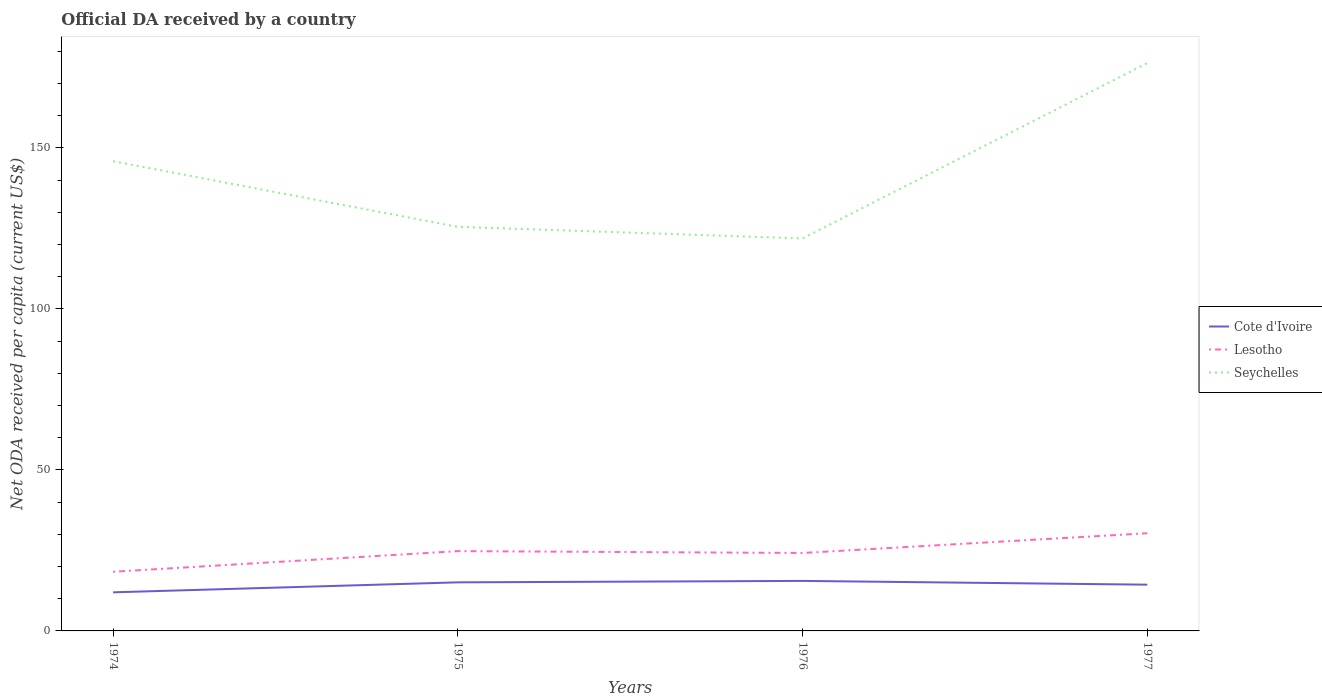How many different coloured lines are there?
Your answer should be very brief. 3. Does the line corresponding to Lesotho intersect with the line corresponding to Cote d'Ivoire?
Provide a succinct answer. No. Is the number of lines equal to the number of legend labels?
Your answer should be very brief. Yes. Across all years, what is the maximum ODA received in in Seychelles?
Make the answer very short. 121.9. In which year was the ODA received in in Seychelles maximum?
Ensure brevity in your answer.  1976. What is the total ODA received in in Seychelles in the graph?
Your answer should be very brief. -50.88. What is the difference between the highest and the second highest ODA received in in Seychelles?
Offer a terse response. 54.48. What is the difference between the highest and the lowest ODA received in in Seychelles?
Give a very brief answer. 2. How many lines are there?
Give a very brief answer. 3. How many years are there in the graph?
Offer a terse response. 4. Are the values on the major ticks of Y-axis written in scientific E-notation?
Keep it short and to the point. No. Where does the legend appear in the graph?
Make the answer very short. Center right. What is the title of the graph?
Offer a very short reply. Official DA received by a country. What is the label or title of the X-axis?
Offer a terse response. Years. What is the label or title of the Y-axis?
Your response must be concise. Net ODA received per capita (current US$). What is the Net ODA received per capita (current US$) of Cote d'Ivoire in 1974?
Give a very brief answer. 11.99. What is the Net ODA received per capita (current US$) in Lesotho in 1974?
Provide a succinct answer. 18.37. What is the Net ODA received per capita (current US$) in Seychelles in 1974?
Keep it short and to the point. 145.9. What is the Net ODA received per capita (current US$) of Cote d'Ivoire in 1975?
Your answer should be compact. 15.09. What is the Net ODA received per capita (current US$) in Lesotho in 1975?
Your response must be concise. 24.78. What is the Net ODA received per capita (current US$) of Seychelles in 1975?
Keep it short and to the point. 125.5. What is the Net ODA received per capita (current US$) of Cote d'Ivoire in 1976?
Ensure brevity in your answer.  15.54. What is the Net ODA received per capita (current US$) in Lesotho in 1976?
Keep it short and to the point. 24.21. What is the Net ODA received per capita (current US$) of Seychelles in 1976?
Keep it short and to the point. 121.9. What is the Net ODA received per capita (current US$) of Cote d'Ivoire in 1977?
Provide a short and direct response. 14.36. What is the Net ODA received per capita (current US$) in Lesotho in 1977?
Your answer should be compact. 30.33. What is the Net ODA received per capita (current US$) in Seychelles in 1977?
Your response must be concise. 176.38. Across all years, what is the maximum Net ODA received per capita (current US$) of Cote d'Ivoire?
Provide a short and direct response. 15.54. Across all years, what is the maximum Net ODA received per capita (current US$) in Lesotho?
Offer a terse response. 30.33. Across all years, what is the maximum Net ODA received per capita (current US$) of Seychelles?
Provide a succinct answer. 176.38. Across all years, what is the minimum Net ODA received per capita (current US$) of Cote d'Ivoire?
Keep it short and to the point. 11.99. Across all years, what is the minimum Net ODA received per capita (current US$) of Lesotho?
Provide a short and direct response. 18.37. Across all years, what is the minimum Net ODA received per capita (current US$) of Seychelles?
Ensure brevity in your answer.  121.9. What is the total Net ODA received per capita (current US$) of Cote d'Ivoire in the graph?
Your answer should be compact. 56.98. What is the total Net ODA received per capita (current US$) in Lesotho in the graph?
Your answer should be compact. 97.7. What is the total Net ODA received per capita (current US$) of Seychelles in the graph?
Offer a very short reply. 569.68. What is the difference between the Net ODA received per capita (current US$) in Cote d'Ivoire in 1974 and that in 1975?
Keep it short and to the point. -3.1. What is the difference between the Net ODA received per capita (current US$) of Lesotho in 1974 and that in 1975?
Your response must be concise. -6.41. What is the difference between the Net ODA received per capita (current US$) in Seychelles in 1974 and that in 1975?
Keep it short and to the point. 20.39. What is the difference between the Net ODA received per capita (current US$) in Cote d'Ivoire in 1974 and that in 1976?
Make the answer very short. -3.55. What is the difference between the Net ODA received per capita (current US$) of Lesotho in 1974 and that in 1976?
Keep it short and to the point. -5.84. What is the difference between the Net ODA received per capita (current US$) in Seychelles in 1974 and that in 1976?
Your answer should be compact. 23.99. What is the difference between the Net ODA received per capita (current US$) of Cote d'Ivoire in 1974 and that in 1977?
Give a very brief answer. -2.37. What is the difference between the Net ODA received per capita (current US$) of Lesotho in 1974 and that in 1977?
Provide a short and direct response. -11.96. What is the difference between the Net ODA received per capita (current US$) in Seychelles in 1974 and that in 1977?
Keep it short and to the point. -30.48. What is the difference between the Net ODA received per capita (current US$) of Cote d'Ivoire in 1975 and that in 1976?
Ensure brevity in your answer.  -0.45. What is the difference between the Net ODA received per capita (current US$) in Lesotho in 1975 and that in 1976?
Provide a short and direct response. 0.57. What is the difference between the Net ODA received per capita (current US$) of Seychelles in 1975 and that in 1976?
Your answer should be very brief. 3.6. What is the difference between the Net ODA received per capita (current US$) of Cote d'Ivoire in 1975 and that in 1977?
Provide a short and direct response. 0.73. What is the difference between the Net ODA received per capita (current US$) in Lesotho in 1975 and that in 1977?
Your answer should be compact. -5.55. What is the difference between the Net ODA received per capita (current US$) of Seychelles in 1975 and that in 1977?
Ensure brevity in your answer.  -50.88. What is the difference between the Net ODA received per capita (current US$) in Cote d'Ivoire in 1976 and that in 1977?
Offer a very short reply. 1.17. What is the difference between the Net ODA received per capita (current US$) of Lesotho in 1976 and that in 1977?
Give a very brief answer. -6.12. What is the difference between the Net ODA received per capita (current US$) in Seychelles in 1976 and that in 1977?
Provide a succinct answer. -54.48. What is the difference between the Net ODA received per capita (current US$) in Cote d'Ivoire in 1974 and the Net ODA received per capita (current US$) in Lesotho in 1975?
Offer a terse response. -12.8. What is the difference between the Net ODA received per capita (current US$) of Cote d'Ivoire in 1974 and the Net ODA received per capita (current US$) of Seychelles in 1975?
Give a very brief answer. -113.52. What is the difference between the Net ODA received per capita (current US$) of Lesotho in 1974 and the Net ODA received per capita (current US$) of Seychelles in 1975?
Keep it short and to the point. -107.13. What is the difference between the Net ODA received per capita (current US$) in Cote d'Ivoire in 1974 and the Net ODA received per capita (current US$) in Lesotho in 1976?
Provide a short and direct response. -12.22. What is the difference between the Net ODA received per capita (current US$) of Cote d'Ivoire in 1974 and the Net ODA received per capita (current US$) of Seychelles in 1976?
Offer a very short reply. -109.91. What is the difference between the Net ODA received per capita (current US$) in Lesotho in 1974 and the Net ODA received per capita (current US$) in Seychelles in 1976?
Your answer should be very brief. -103.53. What is the difference between the Net ODA received per capita (current US$) in Cote d'Ivoire in 1974 and the Net ODA received per capita (current US$) in Lesotho in 1977?
Ensure brevity in your answer.  -18.35. What is the difference between the Net ODA received per capita (current US$) in Cote d'Ivoire in 1974 and the Net ODA received per capita (current US$) in Seychelles in 1977?
Keep it short and to the point. -164.39. What is the difference between the Net ODA received per capita (current US$) in Lesotho in 1974 and the Net ODA received per capita (current US$) in Seychelles in 1977?
Offer a terse response. -158.01. What is the difference between the Net ODA received per capita (current US$) of Cote d'Ivoire in 1975 and the Net ODA received per capita (current US$) of Lesotho in 1976?
Provide a short and direct response. -9.12. What is the difference between the Net ODA received per capita (current US$) in Cote d'Ivoire in 1975 and the Net ODA received per capita (current US$) in Seychelles in 1976?
Your answer should be compact. -106.81. What is the difference between the Net ODA received per capita (current US$) in Lesotho in 1975 and the Net ODA received per capita (current US$) in Seychelles in 1976?
Your answer should be compact. -97.12. What is the difference between the Net ODA received per capita (current US$) in Cote d'Ivoire in 1975 and the Net ODA received per capita (current US$) in Lesotho in 1977?
Offer a very short reply. -15.25. What is the difference between the Net ODA received per capita (current US$) in Cote d'Ivoire in 1975 and the Net ODA received per capita (current US$) in Seychelles in 1977?
Ensure brevity in your answer.  -161.29. What is the difference between the Net ODA received per capita (current US$) of Lesotho in 1975 and the Net ODA received per capita (current US$) of Seychelles in 1977?
Offer a terse response. -151.59. What is the difference between the Net ODA received per capita (current US$) in Cote d'Ivoire in 1976 and the Net ODA received per capita (current US$) in Lesotho in 1977?
Give a very brief answer. -14.8. What is the difference between the Net ODA received per capita (current US$) of Cote d'Ivoire in 1976 and the Net ODA received per capita (current US$) of Seychelles in 1977?
Make the answer very short. -160.84. What is the difference between the Net ODA received per capita (current US$) of Lesotho in 1976 and the Net ODA received per capita (current US$) of Seychelles in 1977?
Provide a succinct answer. -152.17. What is the average Net ODA received per capita (current US$) of Cote d'Ivoire per year?
Give a very brief answer. 14.24. What is the average Net ODA received per capita (current US$) in Lesotho per year?
Give a very brief answer. 24.43. What is the average Net ODA received per capita (current US$) in Seychelles per year?
Your response must be concise. 142.42. In the year 1974, what is the difference between the Net ODA received per capita (current US$) in Cote d'Ivoire and Net ODA received per capita (current US$) in Lesotho?
Keep it short and to the point. -6.38. In the year 1974, what is the difference between the Net ODA received per capita (current US$) of Cote d'Ivoire and Net ODA received per capita (current US$) of Seychelles?
Provide a short and direct response. -133.91. In the year 1974, what is the difference between the Net ODA received per capita (current US$) in Lesotho and Net ODA received per capita (current US$) in Seychelles?
Provide a short and direct response. -127.53. In the year 1975, what is the difference between the Net ODA received per capita (current US$) in Cote d'Ivoire and Net ODA received per capita (current US$) in Lesotho?
Ensure brevity in your answer.  -9.7. In the year 1975, what is the difference between the Net ODA received per capita (current US$) of Cote d'Ivoire and Net ODA received per capita (current US$) of Seychelles?
Offer a terse response. -110.41. In the year 1975, what is the difference between the Net ODA received per capita (current US$) of Lesotho and Net ODA received per capita (current US$) of Seychelles?
Ensure brevity in your answer.  -100.72. In the year 1976, what is the difference between the Net ODA received per capita (current US$) in Cote d'Ivoire and Net ODA received per capita (current US$) in Lesotho?
Give a very brief answer. -8.68. In the year 1976, what is the difference between the Net ODA received per capita (current US$) of Cote d'Ivoire and Net ODA received per capita (current US$) of Seychelles?
Your answer should be very brief. -106.37. In the year 1976, what is the difference between the Net ODA received per capita (current US$) in Lesotho and Net ODA received per capita (current US$) in Seychelles?
Your answer should be compact. -97.69. In the year 1977, what is the difference between the Net ODA received per capita (current US$) of Cote d'Ivoire and Net ODA received per capita (current US$) of Lesotho?
Offer a terse response. -15.97. In the year 1977, what is the difference between the Net ODA received per capita (current US$) in Cote d'Ivoire and Net ODA received per capita (current US$) in Seychelles?
Offer a terse response. -162.02. In the year 1977, what is the difference between the Net ODA received per capita (current US$) in Lesotho and Net ODA received per capita (current US$) in Seychelles?
Your response must be concise. -146.04. What is the ratio of the Net ODA received per capita (current US$) of Cote d'Ivoire in 1974 to that in 1975?
Keep it short and to the point. 0.79. What is the ratio of the Net ODA received per capita (current US$) of Lesotho in 1974 to that in 1975?
Ensure brevity in your answer.  0.74. What is the ratio of the Net ODA received per capita (current US$) of Seychelles in 1974 to that in 1975?
Keep it short and to the point. 1.16. What is the ratio of the Net ODA received per capita (current US$) of Cote d'Ivoire in 1974 to that in 1976?
Keep it short and to the point. 0.77. What is the ratio of the Net ODA received per capita (current US$) of Lesotho in 1974 to that in 1976?
Your response must be concise. 0.76. What is the ratio of the Net ODA received per capita (current US$) in Seychelles in 1974 to that in 1976?
Offer a terse response. 1.2. What is the ratio of the Net ODA received per capita (current US$) in Cote d'Ivoire in 1974 to that in 1977?
Ensure brevity in your answer.  0.83. What is the ratio of the Net ODA received per capita (current US$) of Lesotho in 1974 to that in 1977?
Make the answer very short. 0.61. What is the ratio of the Net ODA received per capita (current US$) of Seychelles in 1974 to that in 1977?
Your response must be concise. 0.83. What is the ratio of the Net ODA received per capita (current US$) of Cote d'Ivoire in 1975 to that in 1976?
Offer a terse response. 0.97. What is the ratio of the Net ODA received per capita (current US$) in Lesotho in 1975 to that in 1976?
Ensure brevity in your answer.  1.02. What is the ratio of the Net ODA received per capita (current US$) of Seychelles in 1975 to that in 1976?
Offer a terse response. 1.03. What is the ratio of the Net ODA received per capita (current US$) in Cote d'Ivoire in 1975 to that in 1977?
Your response must be concise. 1.05. What is the ratio of the Net ODA received per capita (current US$) of Lesotho in 1975 to that in 1977?
Offer a very short reply. 0.82. What is the ratio of the Net ODA received per capita (current US$) of Seychelles in 1975 to that in 1977?
Provide a succinct answer. 0.71. What is the ratio of the Net ODA received per capita (current US$) in Cote d'Ivoire in 1976 to that in 1977?
Offer a very short reply. 1.08. What is the ratio of the Net ODA received per capita (current US$) in Lesotho in 1976 to that in 1977?
Give a very brief answer. 0.8. What is the ratio of the Net ODA received per capita (current US$) of Seychelles in 1976 to that in 1977?
Ensure brevity in your answer.  0.69. What is the difference between the highest and the second highest Net ODA received per capita (current US$) of Cote d'Ivoire?
Give a very brief answer. 0.45. What is the difference between the highest and the second highest Net ODA received per capita (current US$) of Lesotho?
Offer a terse response. 5.55. What is the difference between the highest and the second highest Net ODA received per capita (current US$) of Seychelles?
Your answer should be very brief. 30.48. What is the difference between the highest and the lowest Net ODA received per capita (current US$) of Cote d'Ivoire?
Provide a succinct answer. 3.55. What is the difference between the highest and the lowest Net ODA received per capita (current US$) in Lesotho?
Offer a very short reply. 11.96. What is the difference between the highest and the lowest Net ODA received per capita (current US$) in Seychelles?
Your answer should be compact. 54.48. 